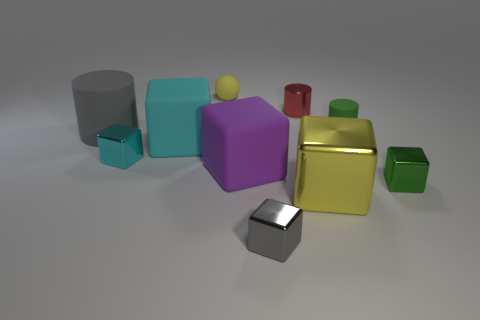There is a tiny object that is left of the cyan rubber block on the right side of the large gray matte object; how many small red metallic cylinders are in front of it?
Make the answer very short. 0. The other large matte thing that is the same shape as the purple object is what color?
Your response must be concise. Cyan. Is there anything else that is the same shape as the tiny yellow matte object?
Your answer should be compact. No. What number of spheres are large rubber objects or tiny metallic objects?
Ensure brevity in your answer.  0. What is the shape of the tiny cyan thing?
Ensure brevity in your answer.  Cube. There is a large yellow block; are there any yellow rubber objects behind it?
Keep it short and to the point. Yes. Are the purple cube and the green thing on the right side of the green matte cylinder made of the same material?
Keep it short and to the point. No. There is a gray object in front of the large cylinder; is it the same shape as the purple thing?
Your response must be concise. Yes. How many small cyan cubes have the same material as the green block?
Your response must be concise. 1. What number of things are either blocks that are on the right side of the yellow rubber ball or small cyan metal things?
Keep it short and to the point. 5. 